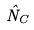Convert formula to latex. <formula><loc_0><loc_0><loc_500><loc_500>\hat { N } _ { C }</formula> 